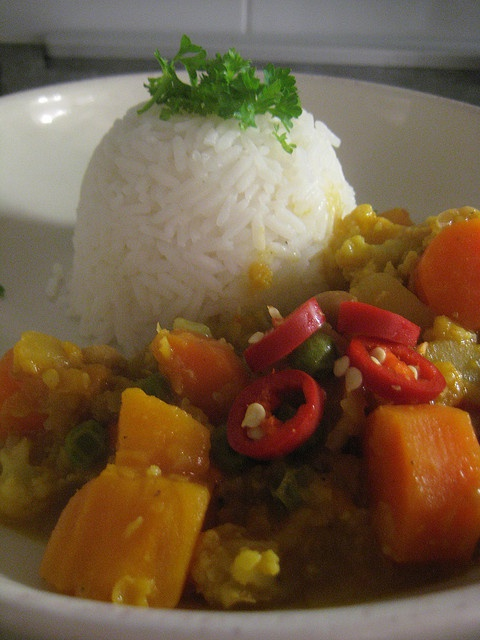Describe the objects in this image and their specific colors. I can see bowl in maroon, gray, black, and olive tones, carrot in gray, olive, and maroon tones, carrot in gray, maroon, and red tones, carrot in gray, maroon, brown, and black tones, and carrot in gray, maroon, brown, and red tones in this image. 